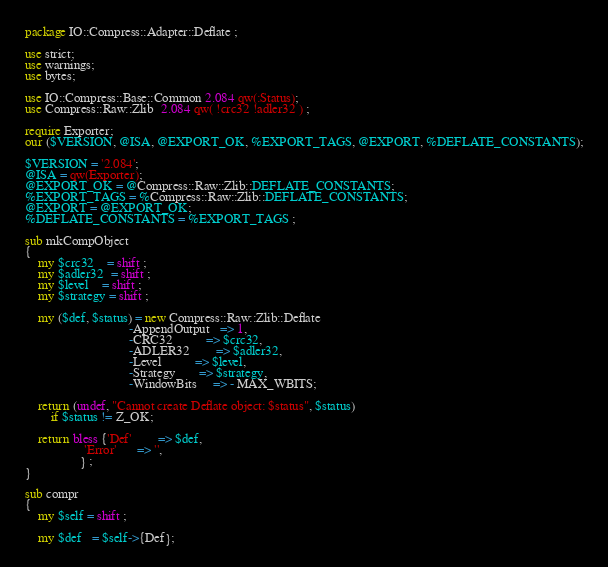<code> <loc_0><loc_0><loc_500><loc_500><_Perl_>package IO::Compress::Adapter::Deflate ;

use strict;
use warnings;
use bytes;

use IO::Compress::Base::Common 2.084 qw(:Status);
use Compress::Raw::Zlib  2.084 qw( !crc32 !adler32 ) ;

require Exporter;
our ($VERSION, @ISA, @EXPORT_OK, %EXPORT_TAGS, @EXPORT, %DEFLATE_CONSTANTS);

$VERSION = '2.084';
@ISA = qw(Exporter);
@EXPORT_OK = @Compress::Raw::Zlib::DEFLATE_CONSTANTS;
%EXPORT_TAGS = %Compress::Raw::Zlib::DEFLATE_CONSTANTS;
@EXPORT = @EXPORT_OK;
%DEFLATE_CONSTANTS = %EXPORT_TAGS ;

sub mkCompObject
{
    my $crc32    = shift ;
    my $adler32  = shift ;
    my $level    = shift ;
    my $strategy = shift ;

    my ($def, $status) = new Compress::Raw::Zlib::Deflate
                                -AppendOutput   => 1,
                                -CRC32          => $crc32,
                                -ADLER32        => $adler32,
                                -Level          => $level,
                                -Strategy       => $strategy,
                                -WindowBits     => - MAX_WBITS;

    return (undef, "Cannot create Deflate object: $status", $status)
        if $status != Z_OK;

    return bless {'Def'        => $def,
                  'Error'      => '',
                 } ;
}

sub compr
{
    my $self = shift ;

    my $def   = $self->{Def};
</code> 